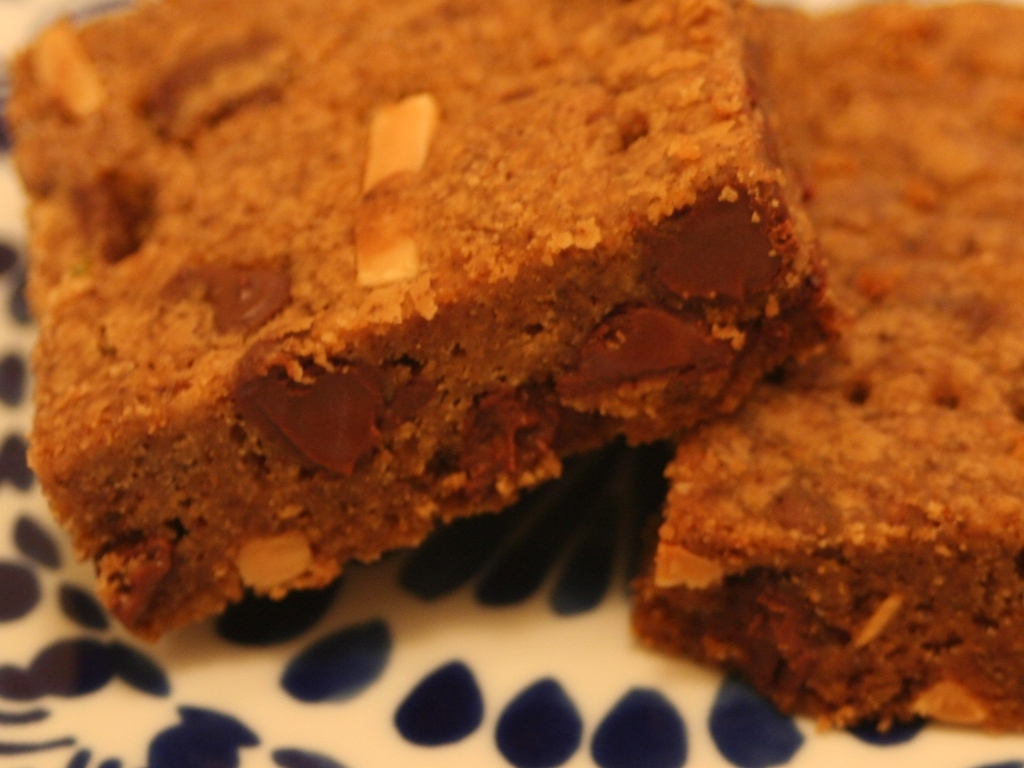What type of dessert is shown in this image? The image displays a delightful arrangement of what appears to be freshly baked brownies, known for their dense, fudgy texture and chocolatey goodness. Can you describe the texture and ingredients that might be in these brownies? Certainly! The texture seems to be soft and moist with a slightly crumbly edge, indicative of a well-prepared brownie. The visible chocolate chunks suggest generous incorporation of chocolate pieces, and the shiny top crust implies the use of eggs and sugar, both of which are common ingredients in brownie recipes. 